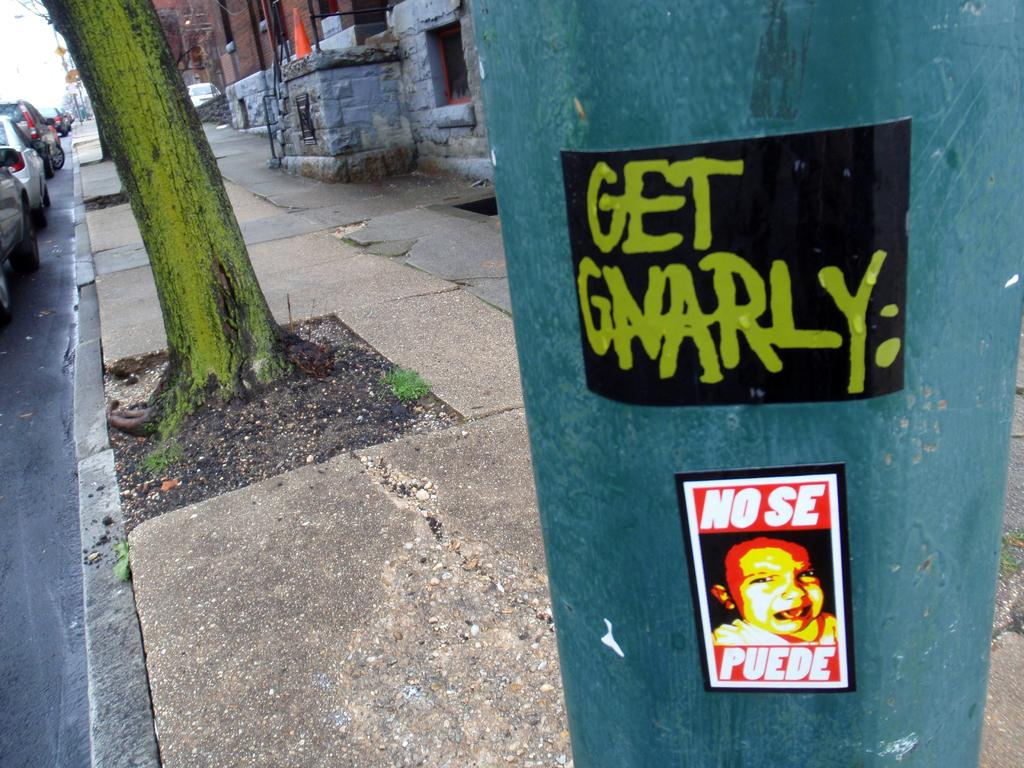<image>
Create a compact narrative representing the image presented. A city light pole in an aging neighborhood has stickers that read Get Gnarly. 